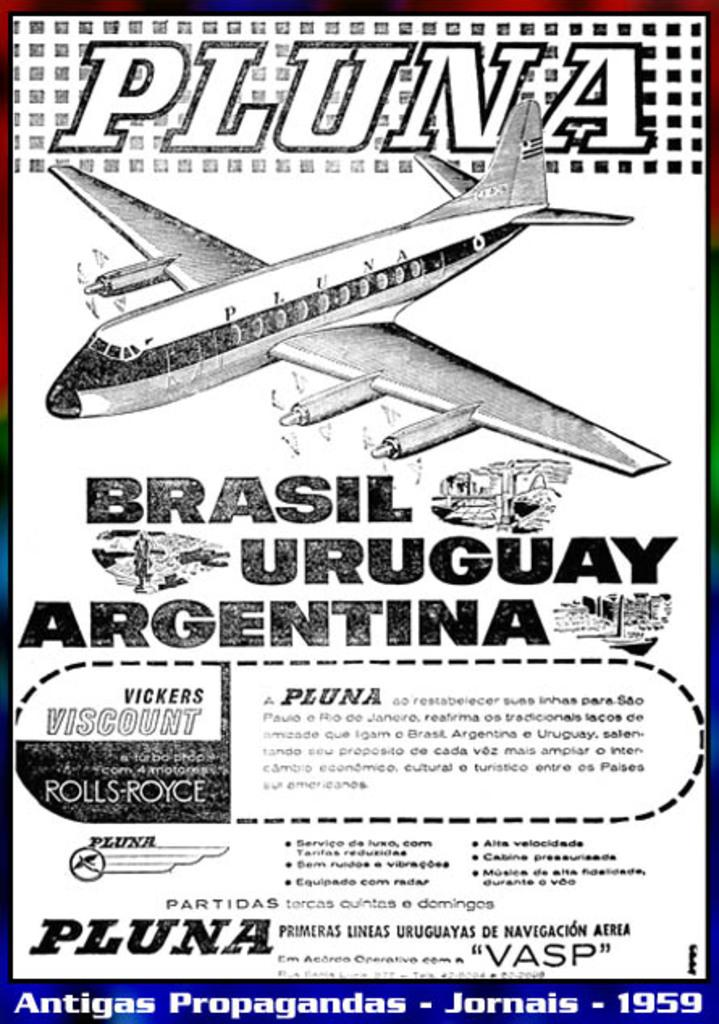<image>
Summarize the visual content of the image. a plane ad that says brasil uruguay and argentina 